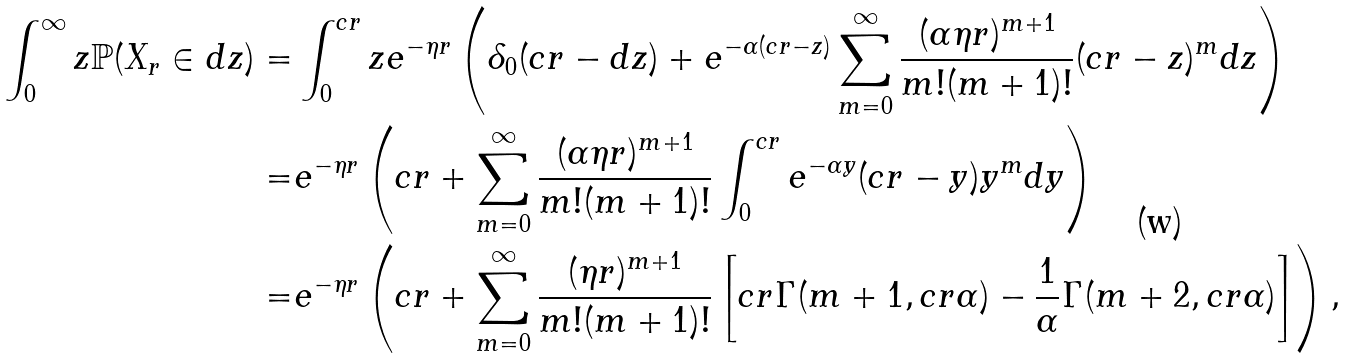Convert formula to latex. <formula><loc_0><loc_0><loc_500><loc_500>\int _ { 0 } ^ { \infty } z \mathbb { P } ( X _ { r } \in d z ) = & \int _ { 0 } ^ { c r } z e ^ { - \eta r } \left ( \delta _ { 0 } ( c r - d z ) + e ^ { - \alpha ( c r - z ) } \sum _ { m = 0 } ^ { \infty } \frac { ( \alpha \eta r ) ^ { m + 1 } } { m ! ( m + 1 ) ! } ( c r - z ) ^ { m } d z \right ) \\ = & e ^ { - \eta r } \left ( c r + \sum _ { m = 0 } ^ { \infty } \frac { ( \alpha \eta r ) ^ { m + 1 } } { m ! ( m + 1 ) ! } \int _ { 0 } ^ { c r } e ^ { - \alpha y } ( c r - y ) y ^ { m } d y \right ) \\ = & e ^ { - \eta r } \left ( c r + \sum _ { m = 0 } ^ { \infty } \frac { ( \eta r ) ^ { m + 1 } } { m ! ( m + 1 ) ! } \left [ c r \Gamma ( m + 1 , c r \alpha ) - \frac { 1 } { \alpha } \Gamma ( m + 2 , c r \alpha ) \right ] \right ) ,</formula> 